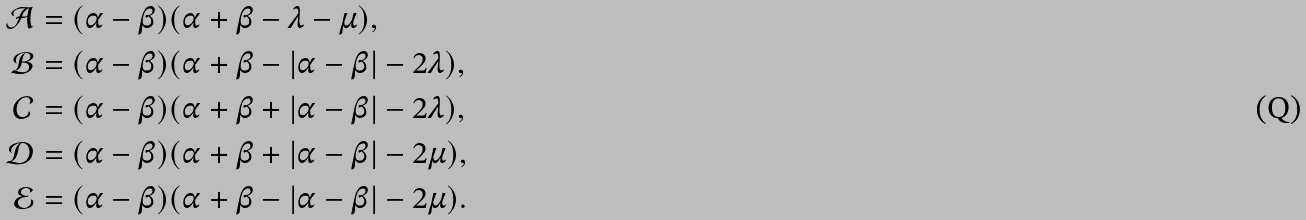<formula> <loc_0><loc_0><loc_500><loc_500>\mathcal { A } & = ( \alpha - \beta ) ( \alpha + \beta - \lambda - \mu ) , \\ \mathcal { B } & = ( \alpha - \beta ) ( \alpha + \beta - | \alpha - \beta | - 2 \lambda ) , \\ \mathcal { C } & = ( \alpha - \beta ) ( \alpha + \beta + | \alpha - \beta | - 2 \lambda ) , \\ \mathcal { D } & = ( \alpha - \beta ) ( \alpha + \beta + | \alpha - \beta | - 2 \mu ) , \\ \mathcal { E } & = ( \alpha - \beta ) ( \alpha + \beta - | \alpha - \beta | - 2 \mu ) .</formula> 